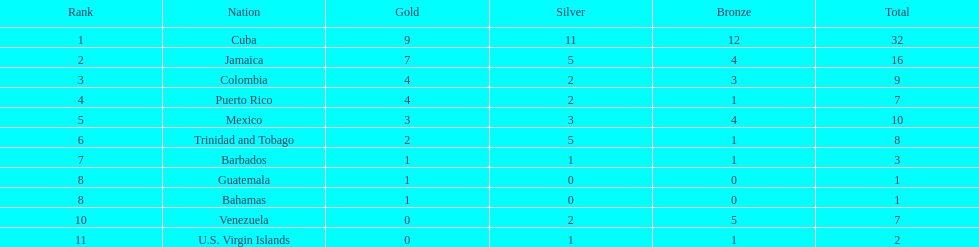Countries with a minimum of 10 medals each Cuba, Jamaica, Mexico. 